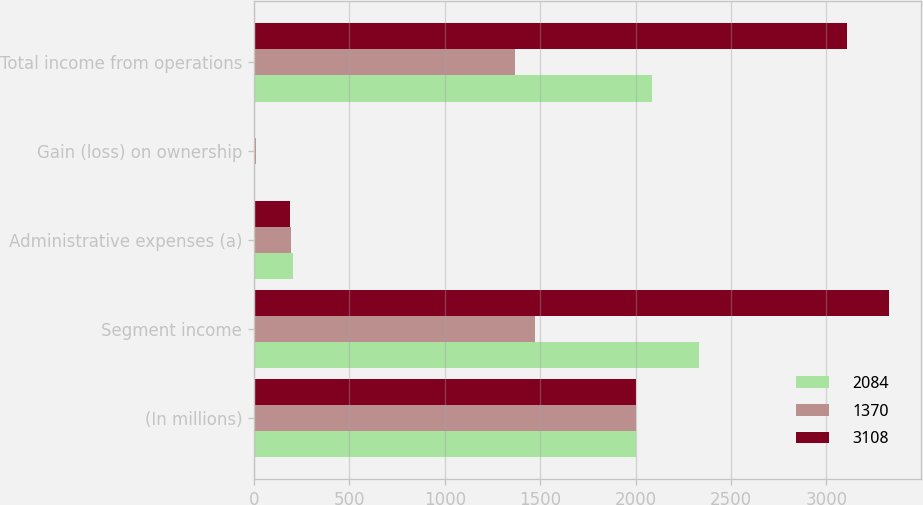<chart> <loc_0><loc_0><loc_500><loc_500><stacked_bar_chart><ecel><fcel>(In millions)<fcel>Segment income<fcel>Administrative expenses (a)<fcel>Gain (loss) on ownership<fcel>Total income from operations<nl><fcel>2084<fcel>2003<fcel>2330<fcel>203<fcel>1<fcel>2084<nl><fcel>1370<fcel>2002<fcel>1472<fcel>194<fcel>12<fcel>1370<nl><fcel>3108<fcel>2001<fcel>3327<fcel>187<fcel>6<fcel>3108<nl></chart> 